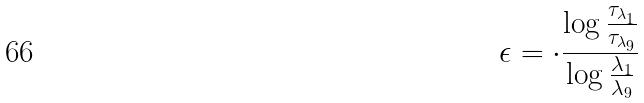Convert formula to latex. <formula><loc_0><loc_0><loc_500><loc_500>\epsilon = \cdot \frac { \log \frac { \tau _ { \lambda _ { 1 } } } { \tau _ { \lambda _ { 9 } } } } { \log \frac { \lambda _ { 1 } } { \lambda _ { 9 } } }</formula> 